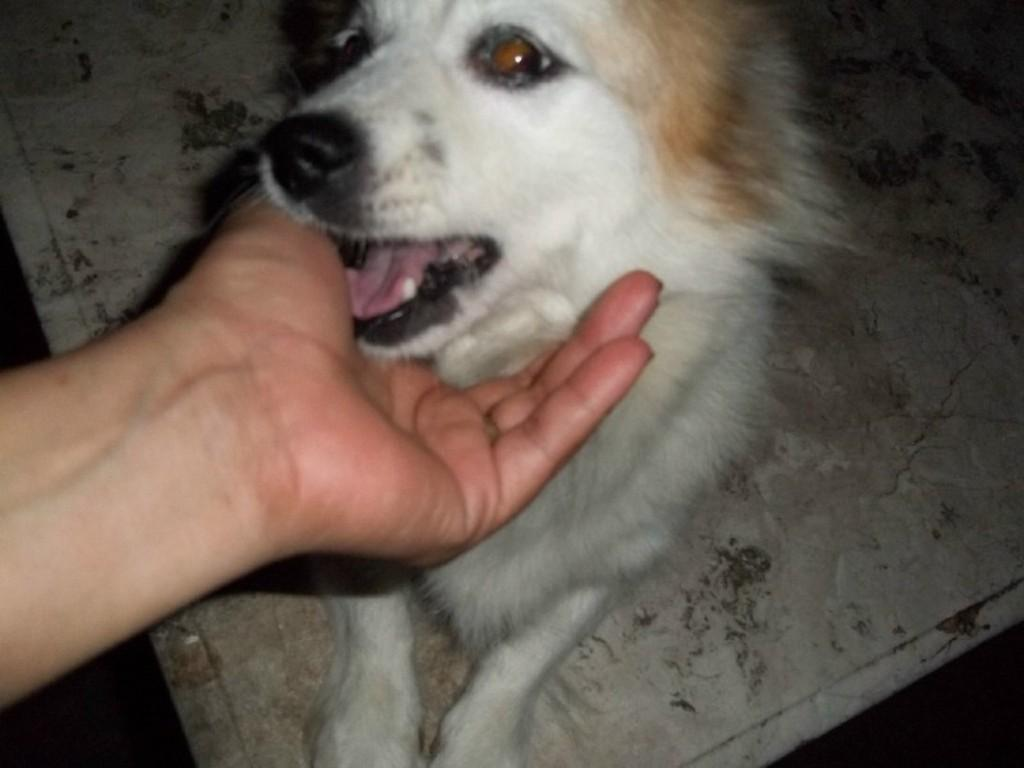What type of animal is in the image? There is a dog in the image. Where is the dog located in the image? The dog is sitting on the floor. What is the person's hand doing in the image? The person's hand is holding the dog's mouth. What type of jeans is the dog wearing in the image? There is no mention of jeans in the image, and dogs do not wear clothing. 